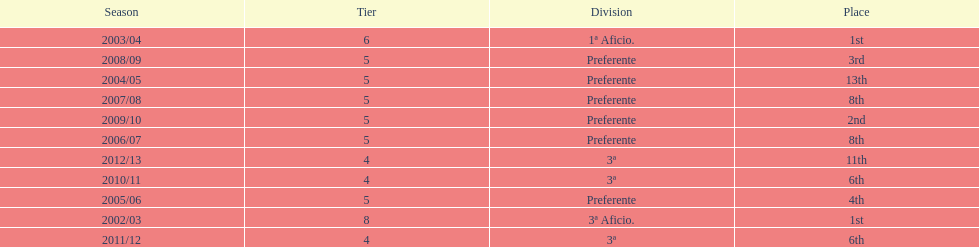How long has internacional de madrid cf been playing in the 3ª division? 3. 